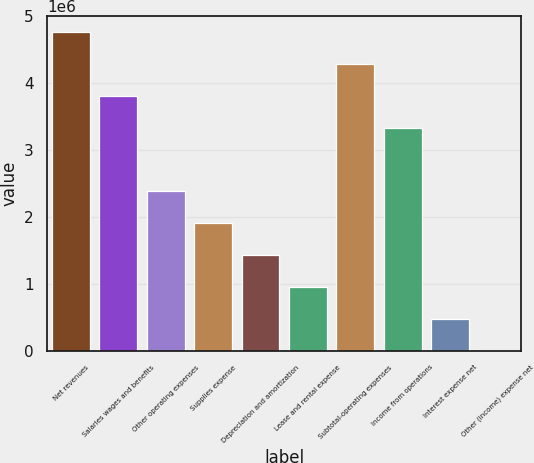<chart> <loc_0><loc_0><loc_500><loc_500><bar_chart><fcel>Net revenues<fcel>Salaries wages and benefits<fcel>Other operating expenses<fcel>Supplies expense<fcel>Depreciation and amortization<fcel>Lease and rental expense<fcel>Subtotal-operating expenses<fcel>Income from operations<fcel>Interest expense net<fcel>Other (income) expense net<nl><fcel>4.76801e+06<fcel>3.81441e+06<fcel>2.38401e+06<fcel>1.9072e+06<fcel>1.4304e+06<fcel>953603<fcel>4.29121e+06<fcel>3.33761e+06<fcel>476803<fcel>1.81<nl></chart> 